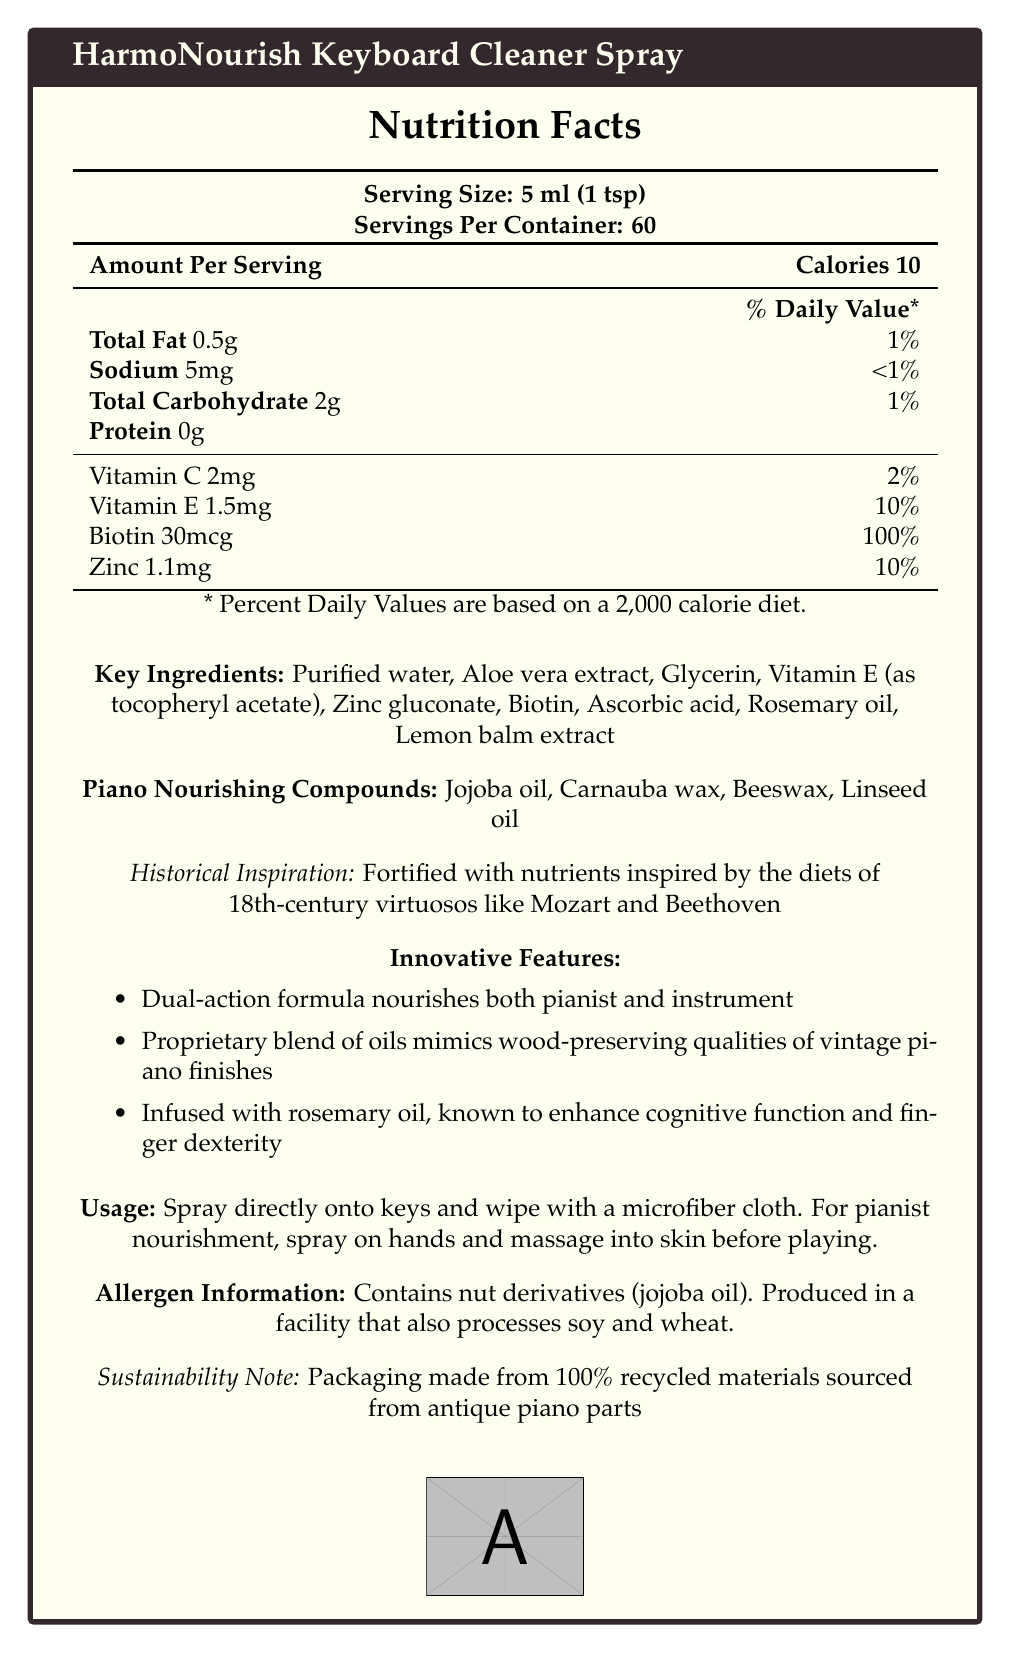what is the serving size of HarmoNourish Keyboard Cleaner Spray? The document states that the serving size is 5 ml, equivalent to 1 teaspoon.
Answer: 5 ml (1 tsp) how many servings are in one container of the cleaner spray? According to the document, there are 60 servings per container.
Answer: 60 how many calories are there per serving? The document lists 10 calories per serving.
Answer: 10 which ingredient provides the highest daily value percentage in a serving? Biotin provides 100% of the daily value in each serving, which is the highest percentage among all listed nutrients.
Answer: Biotin what is the daily value percentage of Vitamin E per serving? The document indicates that each serving contains 1.5 mg of Vitamin E, which is 10% of the daily value.
Answer: 10% which ingredient is not found in the key ingredients list? A. Aloe vera extract B. Rosemary oil C. Coconut oil The document lists purified water, aloe vera extract, glycerin, vitamin E, zinc gluconate, biotin, ascorbic acid, rosemary oil, and lemon balm extract as the key ingredients. Coconut oil is not included.
Answer: C. Coconut oil the daily value of which mineral is provided at 10% per serving? A. Iron B. Zinc C. Calcium Zinc is listed with a daily value of 10% per serving.
Answer: B. Zinc is the packaging of the spray sustainable? The document mentions that the packaging is made from 100% recycled materials sourced from antique piano parts, indicating sustainability.
Answer: Yes describe the main idea of the document. The document provides detailed nutritional facts, key ingredients, innovative features, historical inspirations, usage instructions, allergen information, and sustainability notes. Overall, it emphasizes the multi-purpose nature of the product and its thoughtful design aimed at preserving both the pianist's health and the instrument's condition.
Answer: HarmoNourish Keyboard Cleaner Spray provides nutritional benefits to both pianists and their instruments, featuring a fortified cleaner with key nutrients inspired by historical virtuosos and a dual-action formula. how much biotin does each serving contain? The document states that each serving contains 30 mcg of biotin.
Answer: 30 mcg what historical figures inspired the nutrients fortified in the cleaner spray? The document specifies that the cleaner spray is fortified with nutrients inspired by the diets of 18th-century virtuosos like Mozart and Beethoven.
Answer: Mozart and Beethoven does the document specify the total fat content per serving? The document specifies that the total fat content per serving is 0.5g, representing 1% of the daily value.
Answer: Yes what is the allergen information provided? The document clearly states the allergen information as containing nut derivatives (jojoba oil) and being produced in a facility that processes soy and wheat.
Answer: Contains nut derivatives (jojoba oil). Produced in a facility that also processes soy and wheat. what feature of the cleaner spray is known to enhance cognitive function and finger dexterity? The document mentions that the cleaner spray is infused with rosemary oil, which is known to enhance cognitive function and finger dexterity.
Answer: Rosemary oil how much sodium does each serving contain? The document specifies that each serving contains 5 mg of sodium, which is less than 1% of the daily value.
Answer: 5 mg where are the recycled materials for the packaging sourced from? The document notes that the packaging is made from 100% recycled materials sourced from antique piano parts.
Answer: Antique piano parts what is the main benefit of the proprietary blend of oils in the cleaner spray according to the document? The document states that the proprietary blend of oils mimics the wood-preserving qualities of vintage piano finishes.
Answer: Mimics the wood-preserving qualities of vintage piano finishes is there any information provided on the market price of the cleaner spray? The document does not provide any details on the market price of the cleaner spray.
Answer: Not enough information 